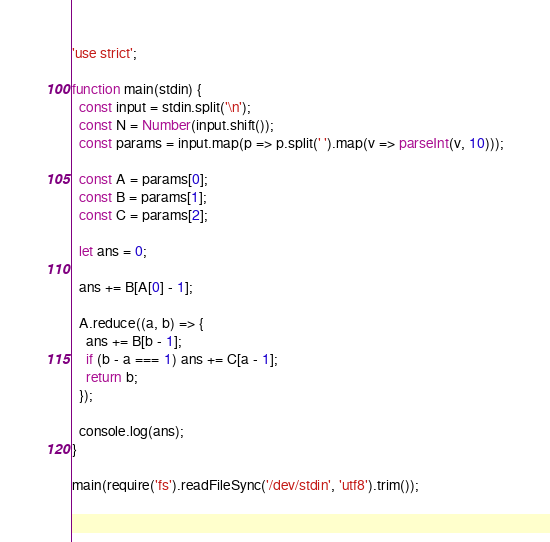<code> <loc_0><loc_0><loc_500><loc_500><_JavaScript_>'use strict';

function main(stdin) {
  const input = stdin.split('\n');
  const N = Number(input.shift());
  const params = input.map(p => p.split(' ').map(v => parseInt(v, 10)));

  const A = params[0];
  const B = params[1];
  const C = params[2];
  
  let ans = 0;

  ans += B[A[0] - 1];

  A.reduce((a, b) => {
    ans += B[b - 1];
    if (b - a === 1) ans += C[a - 1];
    return b;
  });
  
  console.log(ans);
}

main(require('fs').readFileSync('/dev/stdin', 'utf8').trim());</code> 